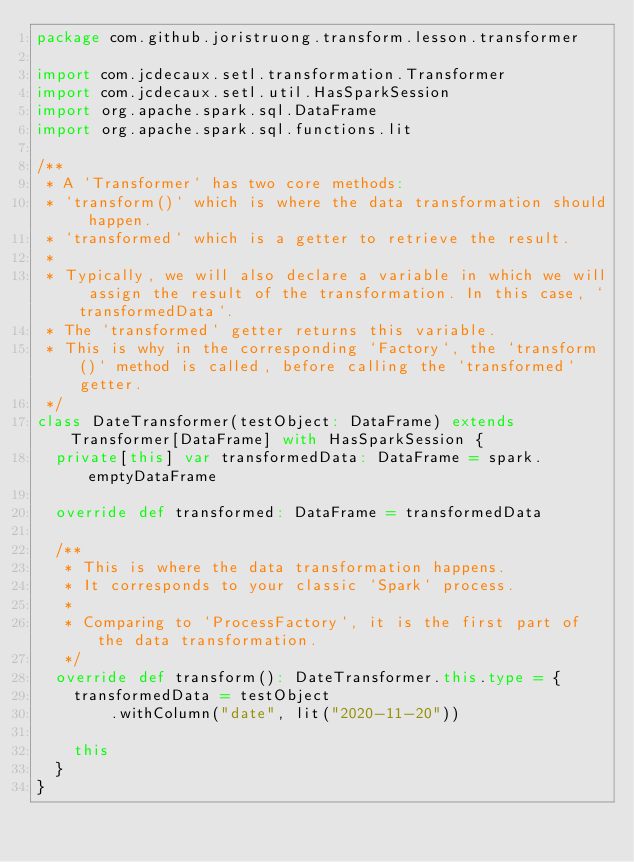<code> <loc_0><loc_0><loc_500><loc_500><_Scala_>package com.github.joristruong.transform.lesson.transformer

import com.jcdecaux.setl.transformation.Transformer
import com.jcdecaux.setl.util.HasSparkSession
import org.apache.spark.sql.DataFrame
import org.apache.spark.sql.functions.lit

/**
 * A `Transformer` has two core methods:
 * `transform()` which is where the data transformation should happen.
 * `transformed` which is a getter to retrieve the result.
 *
 * Typically, we will also declare a variable in which we will assign the result of the transformation. In this case, `transformedData`.
 * The `transformed` getter returns this variable.
 * This is why in the corresponding `Factory`, the `transform()` method is called, before calling the `transformed` getter.
 */
class DateTransformer(testObject: DataFrame) extends Transformer[DataFrame] with HasSparkSession {
  private[this] var transformedData: DataFrame = spark.emptyDataFrame

  override def transformed: DataFrame = transformedData

  /**
   * This is where the data transformation happens.
   * It corresponds to your classic `Spark` process.
   *
   * Comparing to `ProcessFactory`, it is the first part of the data transformation.
   */
  override def transform(): DateTransformer.this.type = {
    transformedData = testObject
        .withColumn("date", lit("2020-11-20"))

    this
  }
}
</code> 